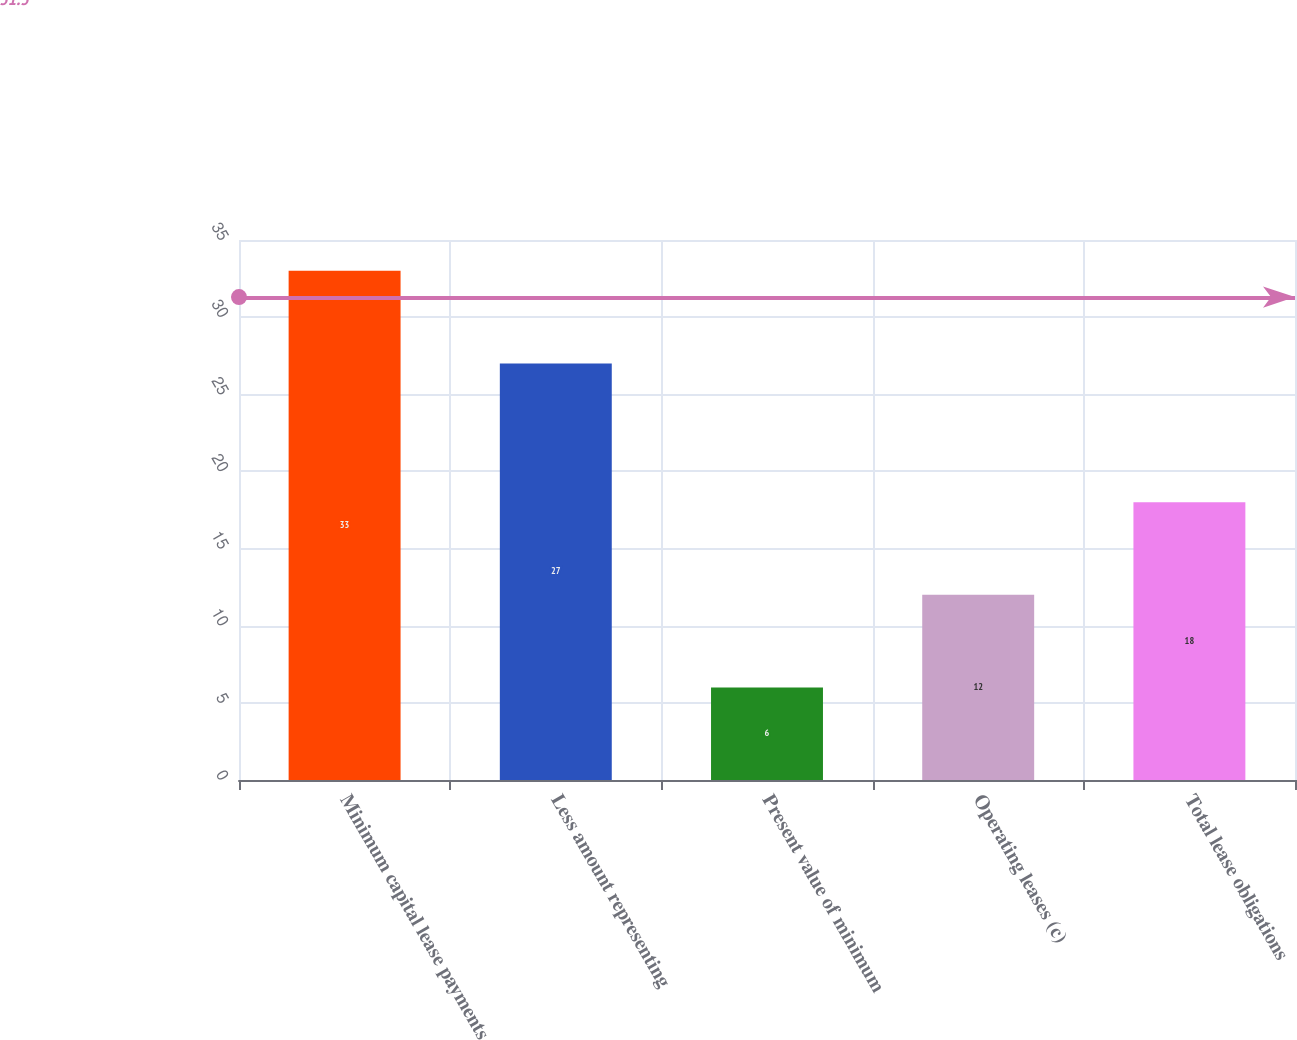<chart> <loc_0><loc_0><loc_500><loc_500><bar_chart><fcel>Minimum capital lease payments<fcel>Less amount representing<fcel>Present value of minimum<fcel>Operating leases (c)<fcel>Total lease obligations<nl><fcel>33<fcel>27<fcel>6<fcel>12<fcel>18<nl></chart> 